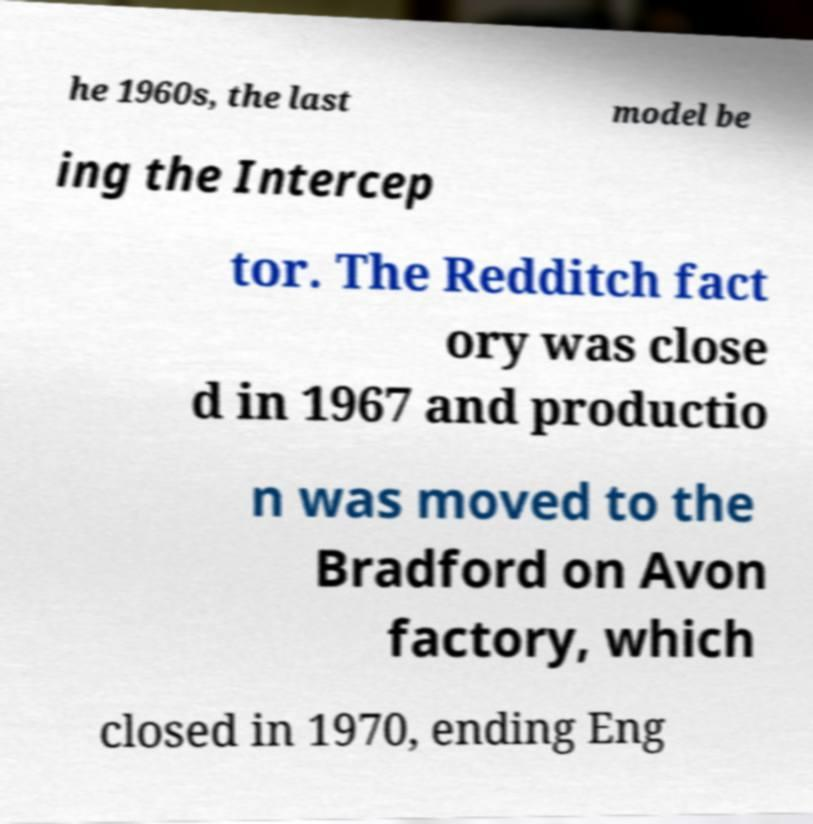What messages or text are displayed in this image? I need them in a readable, typed format. he 1960s, the last model be ing the Intercep tor. The Redditch fact ory was close d in 1967 and productio n was moved to the Bradford on Avon factory, which closed in 1970, ending Eng 